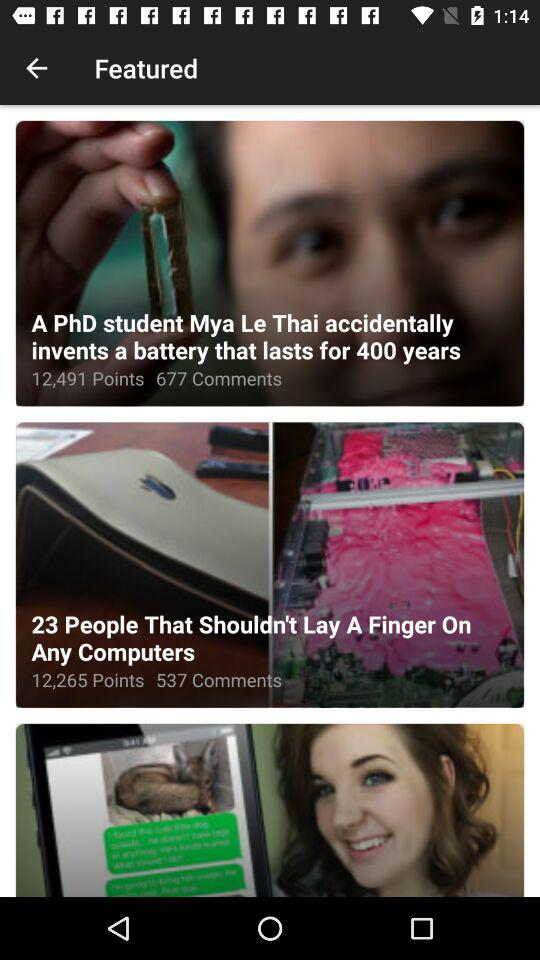How many points are there for "A PhD student Mya Le Thai accidentally invents a battery"? There are 12,491 points. 